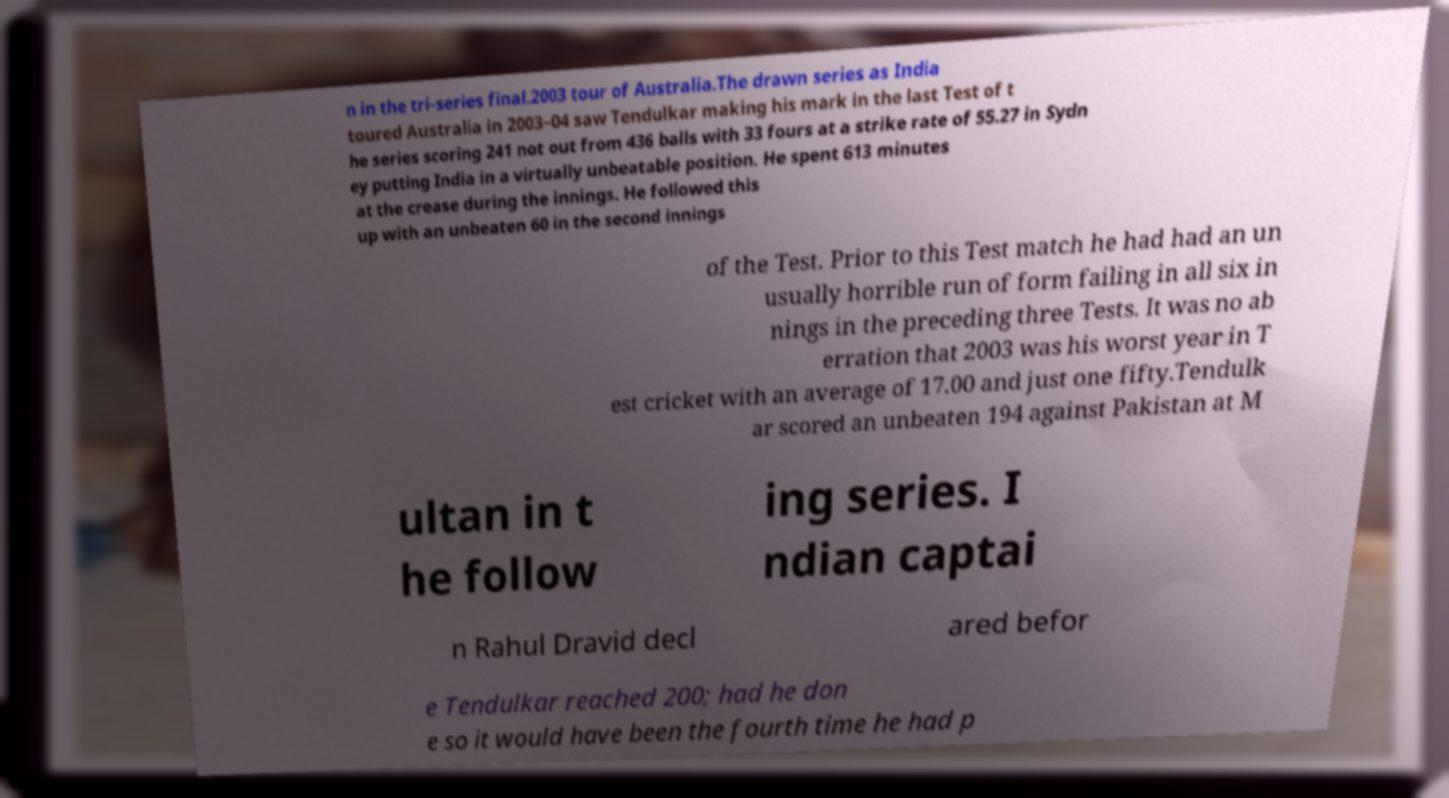There's text embedded in this image that I need extracted. Can you transcribe it verbatim? n in the tri-series final.2003 tour of Australia.The drawn series as India toured Australia in 2003–04 saw Tendulkar making his mark in the last Test of t he series scoring 241 not out from 436 balls with 33 fours at a strike rate of 55.27 in Sydn ey putting India in a virtually unbeatable position. He spent 613 minutes at the crease during the innings. He followed this up with an unbeaten 60 in the second innings of the Test. Prior to this Test match he had had an un usually horrible run of form failing in all six in nings in the preceding three Tests. It was no ab erration that 2003 was his worst year in T est cricket with an average of 17.00 and just one fifty.Tendulk ar scored an unbeaten 194 against Pakistan at M ultan in t he follow ing series. I ndian captai n Rahul Dravid decl ared befor e Tendulkar reached 200; had he don e so it would have been the fourth time he had p 